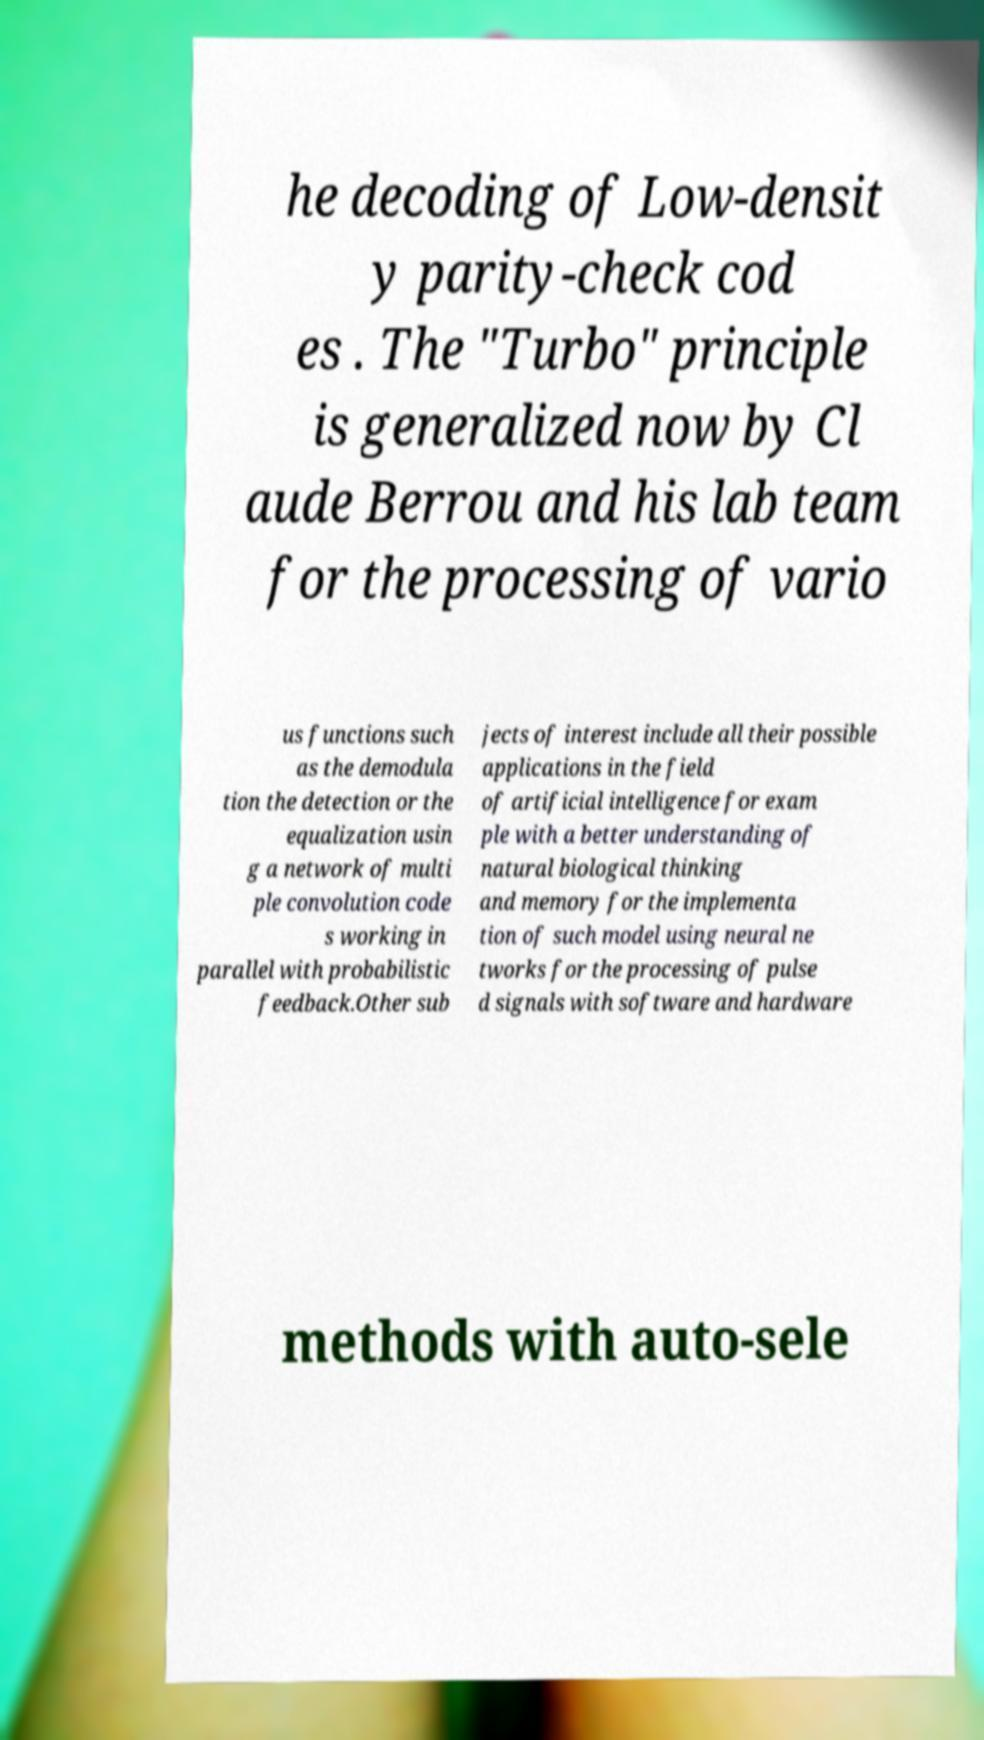What messages or text are displayed in this image? I need them in a readable, typed format. he decoding of Low-densit y parity-check cod es . The "Turbo" principle is generalized now by Cl aude Berrou and his lab team for the processing of vario us functions such as the demodula tion the detection or the equalization usin g a network of multi ple convolution code s working in parallel with probabilistic feedback.Other sub jects of interest include all their possible applications in the field of artificial intelligence for exam ple with a better understanding of natural biological thinking and memory for the implementa tion of such model using neural ne tworks for the processing of pulse d signals with software and hardware methods with auto-sele 